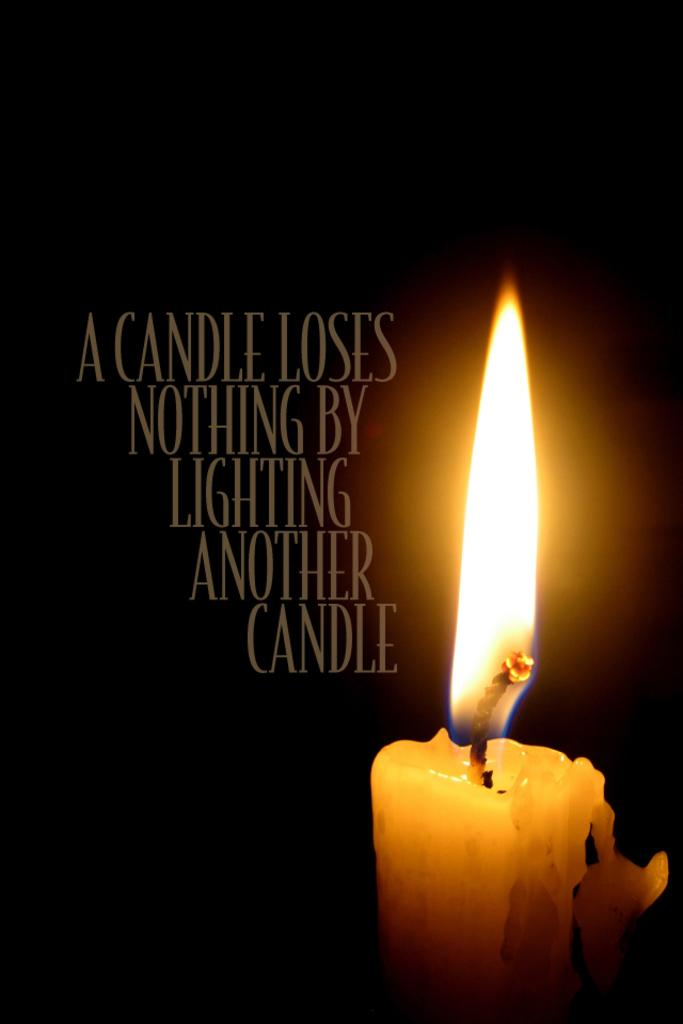What object can be seen in the image that provides light? There is a candle in the image. What else is present in the image besides the candle? There is text in the image. How would you describe the overall appearance of the image? The background of the image is dark. What type of reward is being offered to the insect on the edge of the image? There is no insect present in the image, and therefore no reward is being offered. 